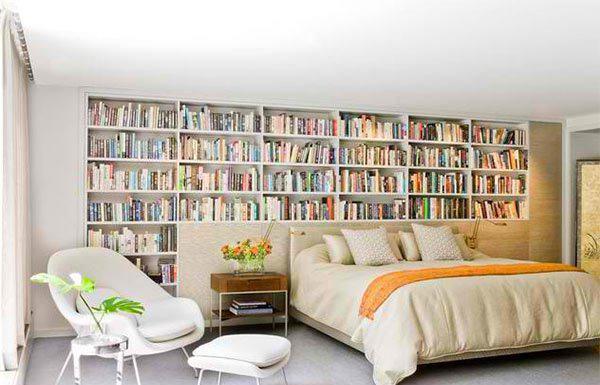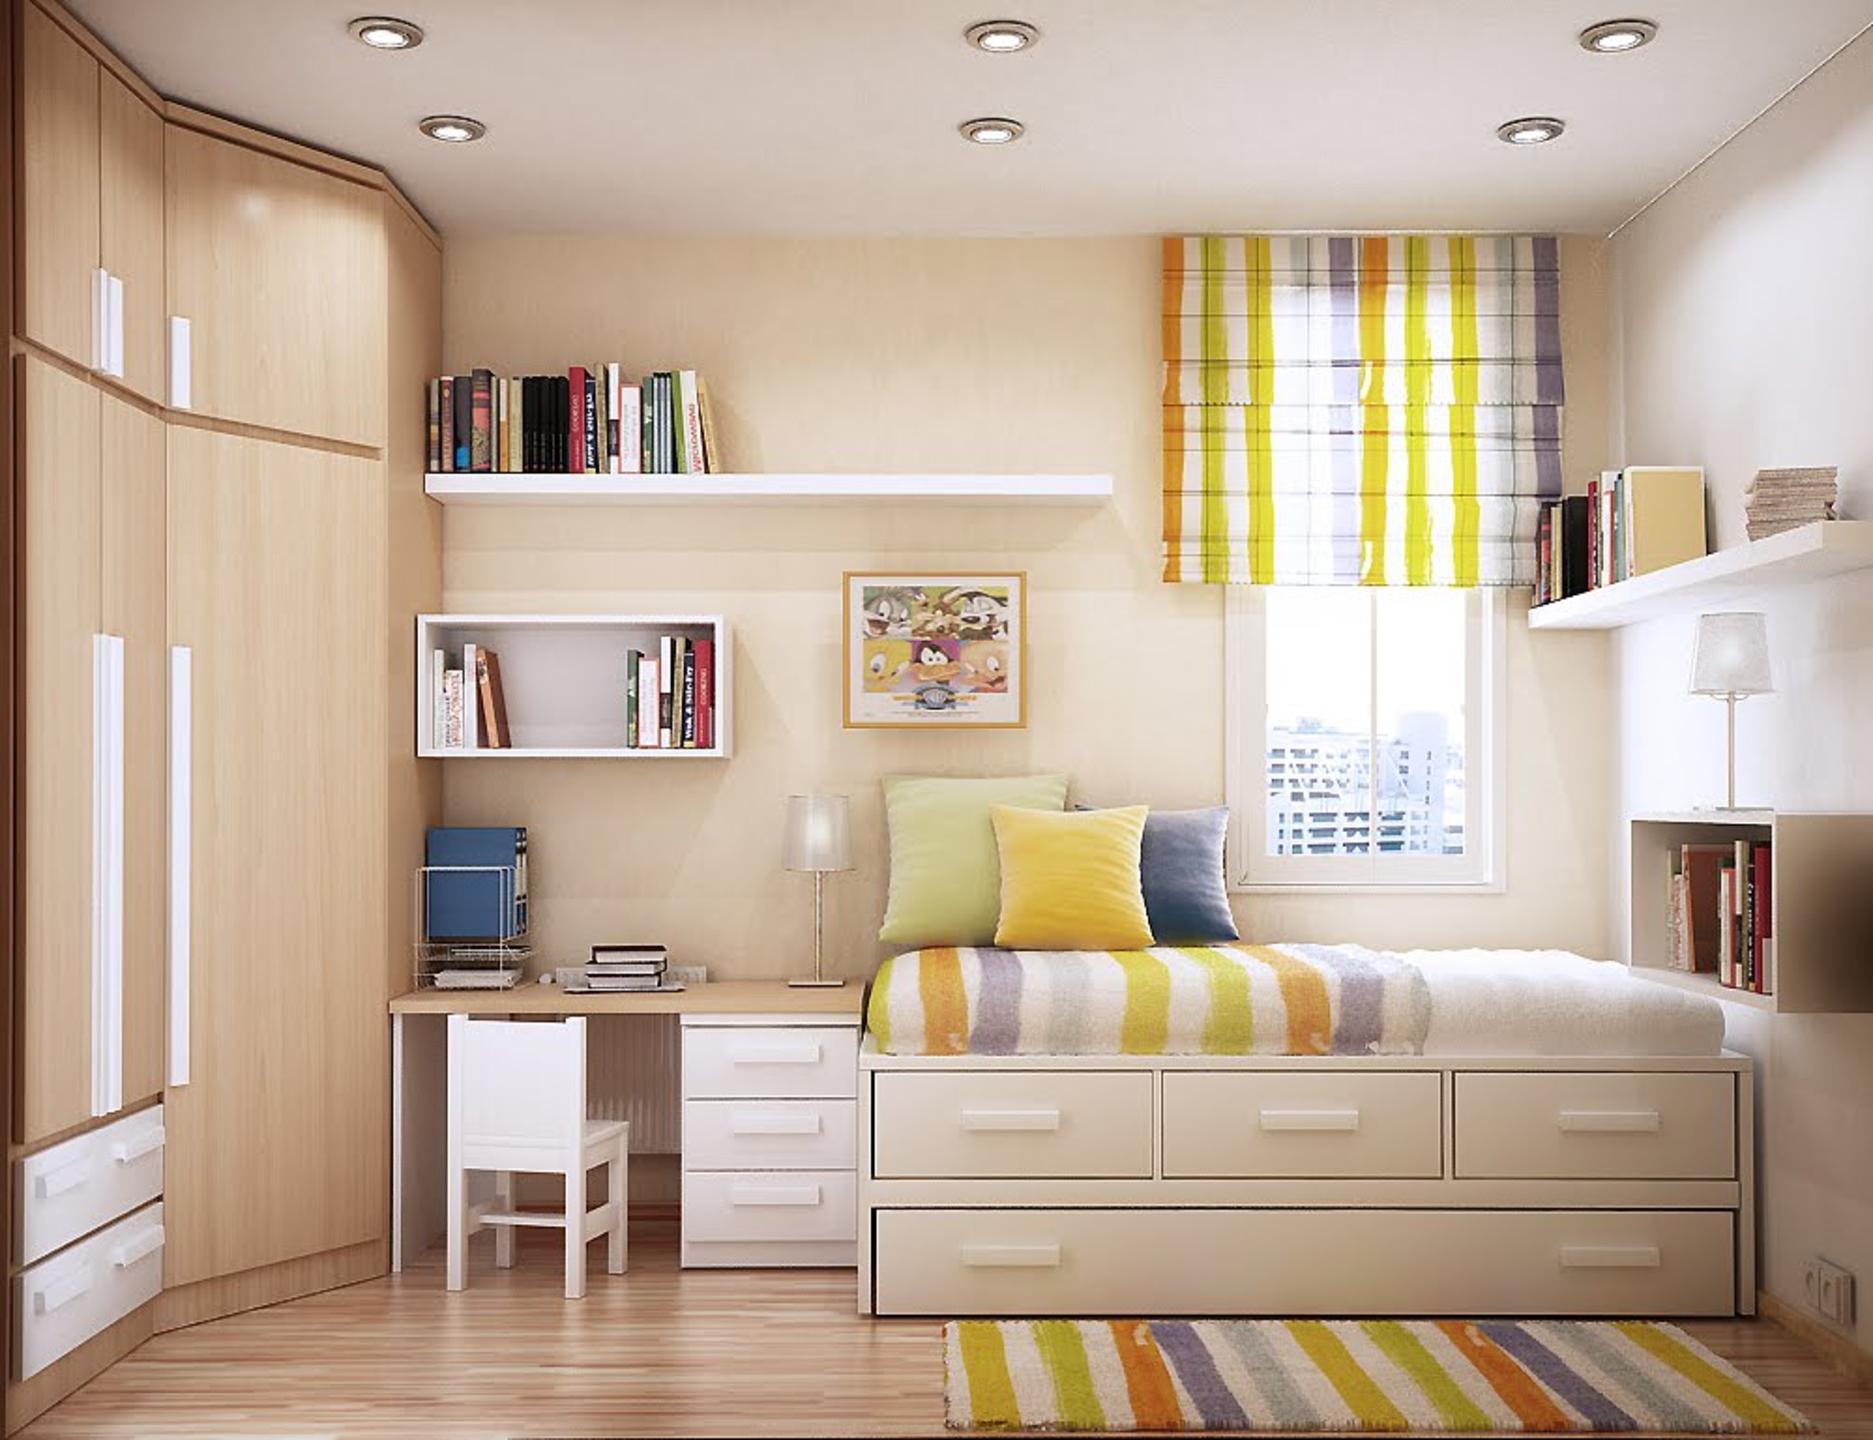The first image is the image on the left, the second image is the image on the right. Examine the images to the left and right. Is the description "A room has a platform bed with storage drawers underneath, and floating shelves on the wall behind it." accurate? Answer yes or no. Yes. 